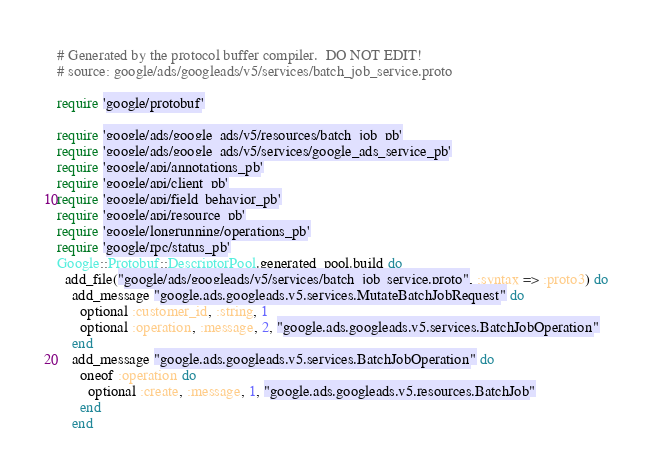<code> <loc_0><loc_0><loc_500><loc_500><_Ruby_># Generated by the protocol buffer compiler.  DO NOT EDIT!
# source: google/ads/googleads/v5/services/batch_job_service.proto

require 'google/protobuf'

require 'google/ads/google_ads/v5/resources/batch_job_pb'
require 'google/ads/google_ads/v5/services/google_ads_service_pb'
require 'google/api/annotations_pb'
require 'google/api/client_pb'
require 'google/api/field_behavior_pb'
require 'google/api/resource_pb'
require 'google/longrunning/operations_pb'
require 'google/rpc/status_pb'
Google::Protobuf::DescriptorPool.generated_pool.build do
  add_file("google/ads/googleads/v5/services/batch_job_service.proto", :syntax => :proto3) do
    add_message "google.ads.googleads.v5.services.MutateBatchJobRequest" do
      optional :customer_id, :string, 1
      optional :operation, :message, 2, "google.ads.googleads.v5.services.BatchJobOperation"
    end
    add_message "google.ads.googleads.v5.services.BatchJobOperation" do
      oneof :operation do
        optional :create, :message, 1, "google.ads.googleads.v5.resources.BatchJob"
      end
    end</code> 